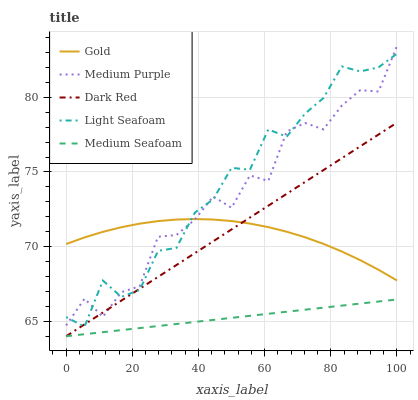Does Medium Seafoam have the minimum area under the curve?
Answer yes or no. Yes. Does Light Seafoam have the maximum area under the curve?
Answer yes or no. Yes. Does Dark Red have the minimum area under the curve?
Answer yes or no. No. Does Dark Red have the maximum area under the curve?
Answer yes or no. No. Is Dark Red the smoothest?
Answer yes or no. Yes. Is Medium Purple the roughest?
Answer yes or no. Yes. Is Light Seafoam the smoothest?
Answer yes or no. No. Is Light Seafoam the roughest?
Answer yes or no. No. Does Dark Red have the lowest value?
Answer yes or no. Yes. Does Light Seafoam have the lowest value?
Answer yes or no. No. Does Medium Purple have the highest value?
Answer yes or no. Yes. Does Dark Red have the highest value?
Answer yes or no. No. Is Medium Seafoam less than Light Seafoam?
Answer yes or no. Yes. Is Light Seafoam greater than Medium Seafoam?
Answer yes or no. Yes. Does Dark Red intersect Light Seafoam?
Answer yes or no. Yes. Is Dark Red less than Light Seafoam?
Answer yes or no. No. Is Dark Red greater than Light Seafoam?
Answer yes or no. No. Does Medium Seafoam intersect Light Seafoam?
Answer yes or no. No. 